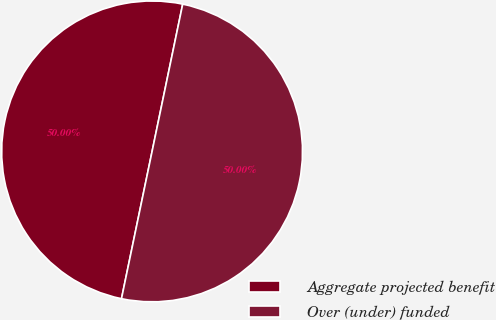Convert chart to OTSL. <chart><loc_0><loc_0><loc_500><loc_500><pie_chart><fcel>Aggregate projected benefit<fcel>Over (under) funded<nl><fcel>50.0%<fcel>50.0%<nl></chart> 